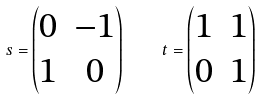Convert formula to latex. <formula><loc_0><loc_0><loc_500><loc_500>s = \begin{pmatrix} 0 & - 1 \\ 1 & 0 \end{pmatrix} \quad t = \begin{pmatrix} 1 & 1 \\ 0 & 1 \end{pmatrix}</formula> 